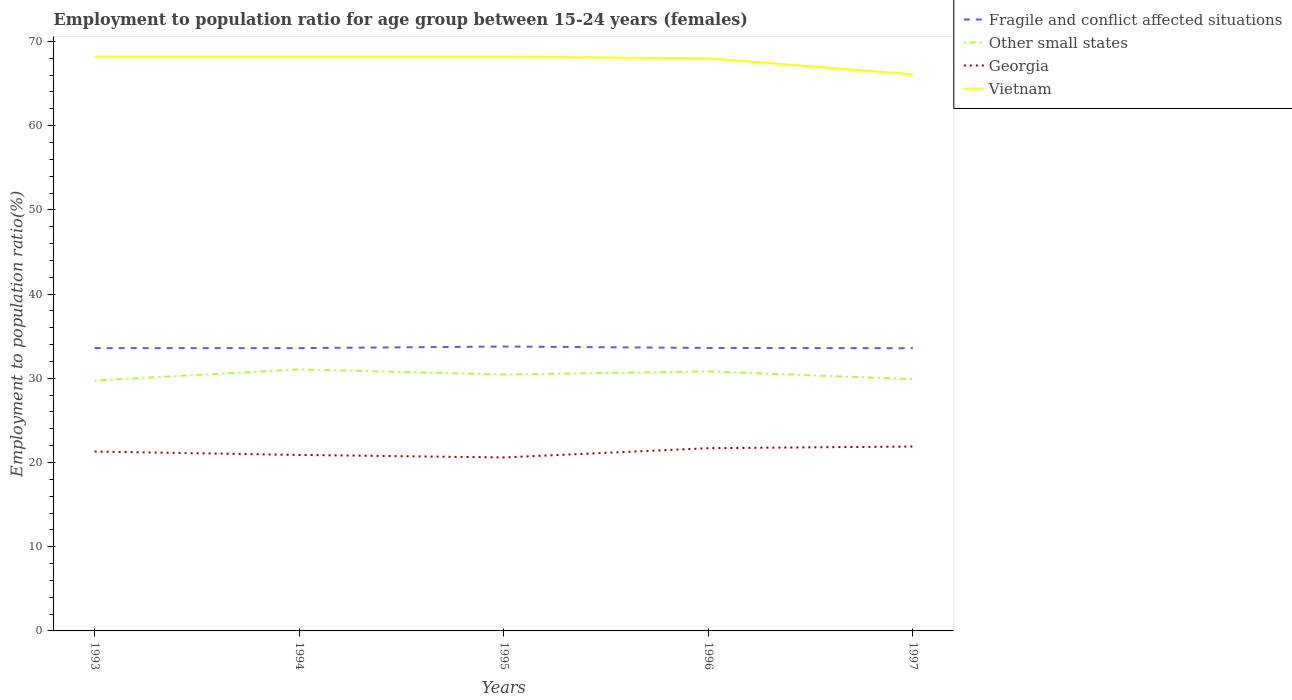How many different coloured lines are there?
Your response must be concise. 4. Does the line corresponding to Vietnam intersect with the line corresponding to Other small states?
Your answer should be very brief. No. Is the number of lines equal to the number of legend labels?
Make the answer very short. Yes. Across all years, what is the maximum employment to population ratio in Fragile and conflict affected situations?
Give a very brief answer. 33.57. In which year was the employment to population ratio in Georgia maximum?
Offer a very short reply. 1995. What is the total employment to population ratio in Georgia in the graph?
Offer a terse response. -1.3. What is the difference between the highest and the second highest employment to population ratio in Other small states?
Make the answer very short. 1.32. What is the difference between the highest and the lowest employment to population ratio in Fragile and conflict affected situations?
Provide a short and direct response. 1. Is the employment to population ratio in Georgia strictly greater than the employment to population ratio in Fragile and conflict affected situations over the years?
Provide a succinct answer. Yes. How many lines are there?
Ensure brevity in your answer.  4. What is the difference between two consecutive major ticks on the Y-axis?
Give a very brief answer. 10. What is the title of the graph?
Offer a very short reply. Employment to population ratio for age group between 15-24 years (females). Does "Fragile and conflict affected situations" appear as one of the legend labels in the graph?
Provide a short and direct response. Yes. What is the label or title of the X-axis?
Your answer should be compact. Years. What is the Employment to population ratio(%) of Fragile and conflict affected situations in 1993?
Your response must be concise. 33.59. What is the Employment to population ratio(%) in Other small states in 1993?
Ensure brevity in your answer.  29.74. What is the Employment to population ratio(%) of Georgia in 1993?
Make the answer very short. 21.3. What is the Employment to population ratio(%) in Vietnam in 1993?
Offer a terse response. 68.2. What is the Employment to population ratio(%) in Fragile and conflict affected situations in 1994?
Offer a very short reply. 33.59. What is the Employment to population ratio(%) in Other small states in 1994?
Your response must be concise. 31.06. What is the Employment to population ratio(%) of Georgia in 1994?
Offer a terse response. 20.9. What is the Employment to population ratio(%) of Vietnam in 1994?
Keep it short and to the point. 68.2. What is the Employment to population ratio(%) in Fragile and conflict affected situations in 1995?
Ensure brevity in your answer.  33.77. What is the Employment to population ratio(%) in Other small states in 1995?
Your answer should be compact. 30.45. What is the Employment to population ratio(%) in Georgia in 1995?
Ensure brevity in your answer.  20.6. What is the Employment to population ratio(%) of Vietnam in 1995?
Your response must be concise. 68.2. What is the Employment to population ratio(%) in Fragile and conflict affected situations in 1996?
Give a very brief answer. 33.6. What is the Employment to population ratio(%) of Other small states in 1996?
Provide a succinct answer. 30.82. What is the Employment to population ratio(%) of Georgia in 1996?
Keep it short and to the point. 21.7. What is the Employment to population ratio(%) of Fragile and conflict affected situations in 1997?
Make the answer very short. 33.57. What is the Employment to population ratio(%) of Other small states in 1997?
Make the answer very short. 29.9. What is the Employment to population ratio(%) of Georgia in 1997?
Keep it short and to the point. 21.9. What is the Employment to population ratio(%) in Vietnam in 1997?
Give a very brief answer. 66.1. Across all years, what is the maximum Employment to population ratio(%) in Fragile and conflict affected situations?
Offer a terse response. 33.77. Across all years, what is the maximum Employment to population ratio(%) in Other small states?
Your answer should be very brief. 31.06. Across all years, what is the maximum Employment to population ratio(%) of Georgia?
Your answer should be compact. 21.9. Across all years, what is the maximum Employment to population ratio(%) in Vietnam?
Ensure brevity in your answer.  68.2. Across all years, what is the minimum Employment to population ratio(%) in Fragile and conflict affected situations?
Provide a succinct answer. 33.57. Across all years, what is the minimum Employment to population ratio(%) of Other small states?
Keep it short and to the point. 29.74. Across all years, what is the minimum Employment to population ratio(%) in Georgia?
Offer a terse response. 20.6. Across all years, what is the minimum Employment to population ratio(%) of Vietnam?
Give a very brief answer. 66.1. What is the total Employment to population ratio(%) in Fragile and conflict affected situations in the graph?
Provide a short and direct response. 168.12. What is the total Employment to population ratio(%) of Other small states in the graph?
Offer a very short reply. 151.96. What is the total Employment to population ratio(%) in Georgia in the graph?
Provide a succinct answer. 106.4. What is the total Employment to population ratio(%) in Vietnam in the graph?
Offer a terse response. 338.7. What is the difference between the Employment to population ratio(%) in Fragile and conflict affected situations in 1993 and that in 1994?
Your answer should be compact. 0. What is the difference between the Employment to population ratio(%) of Other small states in 1993 and that in 1994?
Ensure brevity in your answer.  -1.32. What is the difference between the Employment to population ratio(%) of Fragile and conflict affected situations in 1993 and that in 1995?
Give a very brief answer. -0.19. What is the difference between the Employment to population ratio(%) in Other small states in 1993 and that in 1995?
Offer a very short reply. -0.71. What is the difference between the Employment to population ratio(%) of Georgia in 1993 and that in 1995?
Offer a very short reply. 0.7. What is the difference between the Employment to population ratio(%) in Vietnam in 1993 and that in 1995?
Make the answer very short. 0. What is the difference between the Employment to population ratio(%) of Fragile and conflict affected situations in 1993 and that in 1996?
Ensure brevity in your answer.  -0.02. What is the difference between the Employment to population ratio(%) of Other small states in 1993 and that in 1996?
Provide a succinct answer. -1.08. What is the difference between the Employment to population ratio(%) of Georgia in 1993 and that in 1996?
Offer a terse response. -0.4. What is the difference between the Employment to population ratio(%) in Vietnam in 1993 and that in 1996?
Provide a short and direct response. 0.2. What is the difference between the Employment to population ratio(%) of Fragile and conflict affected situations in 1993 and that in 1997?
Your answer should be compact. 0.01. What is the difference between the Employment to population ratio(%) of Other small states in 1993 and that in 1997?
Keep it short and to the point. -0.17. What is the difference between the Employment to population ratio(%) of Fragile and conflict affected situations in 1994 and that in 1995?
Make the answer very short. -0.19. What is the difference between the Employment to population ratio(%) in Other small states in 1994 and that in 1995?
Give a very brief answer. 0.61. What is the difference between the Employment to population ratio(%) of Georgia in 1994 and that in 1995?
Your response must be concise. 0.3. What is the difference between the Employment to population ratio(%) in Vietnam in 1994 and that in 1995?
Your answer should be very brief. 0. What is the difference between the Employment to population ratio(%) of Fragile and conflict affected situations in 1994 and that in 1996?
Provide a succinct answer. -0.02. What is the difference between the Employment to population ratio(%) of Other small states in 1994 and that in 1996?
Keep it short and to the point. 0.24. What is the difference between the Employment to population ratio(%) in Georgia in 1994 and that in 1996?
Your answer should be compact. -0.8. What is the difference between the Employment to population ratio(%) of Vietnam in 1994 and that in 1996?
Offer a terse response. 0.2. What is the difference between the Employment to population ratio(%) of Fragile and conflict affected situations in 1994 and that in 1997?
Provide a short and direct response. 0.01. What is the difference between the Employment to population ratio(%) in Other small states in 1994 and that in 1997?
Your response must be concise. 1.15. What is the difference between the Employment to population ratio(%) in Georgia in 1994 and that in 1997?
Your answer should be compact. -1. What is the difference between the Employment to population ratio(%) of Fragile and conflict affected situations in 1995 and that in 1996?
Offer a very short reply. 0.17. What is the difference between the Employment to population ratio(%) of Other small states in 1995 and that in 1996?
Provide a succinct answer. -0.37. What is the difference between the Employment to population ratio(%) in Georgia in 1995 and that in 1996?
Offer a terse response. -1.1. What is the difference between the Employment to population ratio(%) in Fragile and conflict affected situations in 1995 and that in 1997?
Your answer should be very brief. 0.2. What is the difference between the Employment to population ratio(%) in Other small states in 1995 and that in 1997?
Your answer should be very brief. 0.54. What is the difference between the Employment to population ratio(%) of Vietnam in 1995 and that in 1997?
Keep it short and to the point. 2.1. What is the difference between the Employment to population ratio(%) of Fragile and conflict affected situations in 1996 and that in 1997?
Ensure brevity in your answer.  0.03. What is the difference between the Employment to population ratio(%) of Other small states in 1996 and that in 1997?
Provide a succinct answer. 0.91. What is the difference between the Employment to population ratio(%) in Vietnam in 1996 and that in 1997?
Provide a short and direct response. 1.9. What is the difference between the Employment to population ratio(%) of Fragile and conflict affected situations in 1993 and the Employment to population ratio(%) of Other small states in 1994?
Offer a very short reply. 2.53. What is the difference between the Employment to population ratio(%) in Fragile and conflict affected situations in 1993 and the Employment to population ratio(%) in Georgia in 1994?
Offer a very short reply. 12.69. What is the difference between the Employment to population ratio(%) in Fragile and conflict affected situations in 1993 and the Employment to population ratio(%) in Vietnam in 1994?
Your answer should be compact. -34.61. What is the difference between the Employment to population ratio(%) in Other small states in 1993 and the Employment to population ratio(%) in Georgia in 1994?
Give a very brief answer. 8.84. What is the difference between the Employment to population ratio(%) in Other small states in 1993 and the Employment to population ratio(%) in Vietnam in 1994?
Ensure brevity in your answer.  -38.46. What is the difference between the Employment to population ratio(%) in Georgia in 1993 and the Employment to population ratio(%) in Vietnam in 1994?
Your answer should be compact. -46.9. What is the difference between the Employment to population ratio(%) in Fragile and conflict affected situations in 1993 and the Employment to population ratio(%) in Other small states in 1995?
Offer a terse response. 3.14. What is the difference between the Employment to population ratio(%) in Fragile and conflict affected situations in 1993 and the Employment to population ratio(%) in Georgia in 1995?
Provide a succinct answer. 12.99. What is the difference between the Employment to population ratio(%) of Fragile and conflict affected situations in 1993 and the Employment to population ratio(%) of Vietnam in 1995?
Offer a terse response. -34.61. What is the difference between the Employment to population ratio(%) in Other small states in 1993 and the Employment to population ratio(%) in Georgia in 1995?
Your answer should be very brief. 9.14. What is the difference between the Employment to population ratio(%) of Other small states in 1993 and the Employment to population ratio(%) of Vietnam in 1995?
Your answer should be compact. -38.46. What is the difference between the Employment to population ratio(%) in Georgia in 1993 and the Employment to population ratio(%) in Vietnam in 1995?
Your answer should be compact. -46.9. What is the difference between the Employment to population ratio(%) in Fragile and conflict affected situations in 1993 and the Employment to population ratio(%) in Other small states in 1996?
Provide a succinct answer. 2.77. What is the difference between the Employment to population ratio(%) of Fragile and conflict affected situations in 1993 and the Employment to population ratio(%) of Georgia in 1996?
Make the answer very short. 11.89. What is the difference between the Employment to population ratio(%) in Fragile and conflict affected situations in 1993 and the Employment to population ratio(%) in Vietnam in 1996?
Make the answer very short. -34.41. What is the difference between the Employment to population ratio(%) of Other small states in 1993 and the Employment to population ratio(%) of Georgia in 1996?
Provide a succinct answer. 8.04. What is the difference between the Employment to population ratio(%) of Other small states in 1993 and the Employment to population ratio(%) of Vietnam in 1996?
Provide a succinct answer. -38.26. What is the difference between the Employment to population ratio(%) of Georgia in 1993 and the Employment to population ratio(%) of Vietnam in 1996?
Your response must be concise. -46.7. What is the difference between the Employment to population ratio(%) of Fragile and conflict affected situations in 1993 and the Employment to population ratio(%) of Other small states in 1997?
Provide a short and direct response. 3.68. What is the difference between the Employment to population ratio(%) in Fragile and conflict affected situations in 1993 and the Employment to population ratio(%) in Georgia in 1997?
Your answer should be compact. 11.69. What is the difference between the Employment to population ratio(%) in Fragile and conflict affected situations in 1993 and the Employment to population ratio(%) in Vietnam in 1997?
Provide a short and direct response. -32.51. What is the difference between the Employment to population ratio(%) in Other small states in 1993 and the Employment to population ratio(%) in Georgia in 1997?
Offer a terse response. 7.84. What is the difference between the Employment to population ratio(%) in Other small states in 1993 and the Employment to population ratio(%) in Vietnam in 1997?
Your answer should be compact. -36.36. What is the difference between the Employment to population ratio(%) of Georgia in 1993 and the Employment to population ratio(%) of Vietnam in 1997?
Your answer should be very brief. -44.8. What is the difference between the Employment to population ratio(%) in Fragile and conflict affected situations in 1994 and the Employment to population ratio(%) in Other small states in 1995?
Your answer should be compact. 3.14. What is the difference between the Employment to population ratio(%) in Fragile and conflict affected situations in 1994 and the Employment to population ratio(%) in Georgia in 1995?
Provide a succinct answer. 12.99. What is the difference between the Employment to population ratio(%) in Fragile and conflict affected situations in 1994 and the Employment to population ratio(%) in Vietnam in 1995?
Your answer should be very brief. -34.61. What is the difference between the Employment to population ratio(%) in Other small states in 1994 and the Employment to population ratio(%) in Georgia in 1995?
Give a very brief answer. 10.46. What is the difference between the Employment to population ratio(%) in Other small states in 1994 and the Employment to population ratio(%) in Vietnam in 1995?
Give a very brief answer. -37.14. What is the difference between the Employment to population ratio(%) in Georgia in 1994 and the Employment to population ratio(%) in Vietnam in 1995?
Your response must be concise. -47.3. What is the difference between the Employment to population ratio(%) in Fragile and conflict affected situations in 1994 and the Employment to population ratio(%) in Other small states in 1996?
Ensure brevity in your answer.  2.77. What is the difference between the Employment to population ratio(%) in Fragile and conflict affected situations in 1994 and the Employment to population ratio(%) in Georgia in 1996?
Your answer should be compact. 11.89. What is the difference between the Employment to population ratio(%) in Fragile and conflict affected situations in 1994 and the Employment to population ratio(%) in Vietnam in 1996?
Your answer should be compact. -34.41. What is the difference between the Employment to population ratio(%) in Other small states in 1994 and the Employment to population ratio(%) in Georgia in 1996?
Make the answer very short. 9.36. What is the difference between the Employment to population ratio(%) in Other small states in 1994 and the Employment to population ratio(%) in Vietnam in 1996?
Your answer should be very brief. -36.94. What is the difference between the Employment to population ratio(%) in Georgia in 1994 and the Employment to population ratio(%) in Vietnam in 1996?
Keep it short and to the point. -47.1. What is the difference between the Employment to population ratio(%) in Fragile and conflict affected situations in 1994 and the Employment to population ratio(%) in Other small states in 1997?
Provide a succinct answer. 3.68. What is the difference between the Employment to population ratio(%) of Fragile and conflict affected situations in 1994 and the Employment to population ratio(%) of Georgia in 1997?
Offer a very short reply. 11.69. What is the difference between the Employment to population ratio(%) of Fragile and conflict affected situations in 1994 and the Employment to population ratio(%) of Vietnam in 1997?
Your response must be concise. -32.51. What is the difference between the Employment to population ratio(%) of Other small states in 1994 and the Employment to population ratio(%) of Georgia in 1997?
Provide a short and direct response. 9.16. What is the difference between the Employment to population ratio(%) in Other small states in 1994 and the Employment to population ratio(%) in Vietnam in 1997?
Your response must be concise. -35.04. What is the difference between the Employment to population ratio(%) in Georgia in 1994 and the Employment to population ratio(%) in Vietnam in 1997?
Ensure brevity in your answer.  -45.2. What is the difference between the Employment to population ratio(%) of Fragile and conflict affected situations in 1995 and the Employment to population ratio(%) of Other small states in 1996?
Give a very brief answer. 2.96. What is the difference between the Employment to population ratio(%) in Fragile and conflict affected situations in 1995 and the Employment to population ratio(%) in Georgia in 1996?
Your response must be concise. 12.07. What is the difference between the Employment to population ratio(%) of Fragile and conflict affected situations in 1995 and the Employment to population ratio(%) of Vietnam in 1996?
Your response must be concise. -34.23. What is the difference between the Employment to population ratio(%) in Other small states in 1995 and the Employment to population ratio(%) in Georgia in 1996?
Make the answer very short. 8.75. What is the difference between the Employment to population ratio(%) in Other small states in 1995 and the Employment to population ratio(%) in Vietnam in 1996?
Make the answer very short. -37.55. What is the difference between the Employment to population ratio(%) in Georgia in 1995 and the Employment to population ratio(%) in Vietnam in 1996?
Make the answer very short. -47.4. What is the difference between the Employment to population ratio(%) in Fragile and conflict affected situations in 1995 and the Employment to population ratio(%) in Other small states in 1997?
Ensure brevity in your answer.  3.87. What is the difference between the Employment to population ratio(%) in Fragile and conflict affected situations in 1995 and the Employment to population ratio(%) in Georgia in 1997?
Your answer should be compact. 11.87. What is the difference between the Employment to population ratio(%) of Fragile and conflict affected situations in 1995 and the Employment to population ratio(%) of Vietnam in 1997?
Your answer should be very brief. -32.33. What is the difference between the Employment to population ratio(%) in Other small states in 1995 and the Employment to population ratio(%) in Georgia in 1997?
Make the answer very short. 8.55. What is the difference between the Employment to population ratio(%) of Other small states in 1995 and the Employment to population ratio(%) of Vietnam in 1997?
Give a very brief answer. -35.65. What is the difference between the Employment to population ratio(%) in Georgia in 1995 and the Employment to population ratio(%) in Vietnam in 1997?
Give a very brief answer. -45.5. What is the difference between the Employment to population ratio(%) in Fragile and conflict affected situations in 1996 and the Employment to population ratio(%) in Other small states in 1997?
Ensure brevity in your answer.  3.7. What is the difference between the Employment to population ratio(%) of Fragile and conflict affected situations in 1996 and the Employment to population ratio(%) of Georgia in 1997?
Offer a very short reply. 11.7. What is the difference between the Employment to population ratio(%) of Fragile and conflict affected situations in 1996 and the Employment to population ratio(%) of Vietnam in 1997?
Your response must be concise. -32.5. What is the difference between the Employment to population ratio(%) of Other small states in 1996 and the Employment to population ratio(%) of Georgia in 1997?
Give a very brief answer. 8.92. What is the difference between the Employment to population ratio(%) in Other small states in 1996 and the Employment to population ratio(%) in Vietnam in 1997?
Offer a very short reply. -35.28. What is the difference between the Employment to population ratio(%) in Georgia in 1996 and the Employment to population ratio(%) in Vietnam in 1997?
Your response must be concise. -44.4. What is the average Employment to population ratio(%) of Fragile and conflict affected situations per year?
Your answer should be very brief. 33.62. What is the average Employment to population ratio(%) of Other small states per year?
Give a very brief answer. 30.39. What is the average Employment to population ratio(%) in Georgia per year?
Your answer should be compact. 21.28. What is the average Employment to population ratio(%) of Vietnam per year?
Give a very brief answer. 67.74. In the year 1993, what is the difference between the Employment to population ratio(%) of Fragile and conflict affected situations and Employment to population ratio(%) of Other small states?
Provide a short and direct response. 3.85. In the year 1993, what is the difference between the Employment to population ratio(%) of Fragile and conflict affected situations and Employment to population ratio(%) of Georgia?
Your response must be concise. 12.29. In the year 1993, what is the difference between the Employment to population ratio(%) of Fragile and conflict affected situations and Employment to population ratio(%) of Vietnam?
Your answer should be very brief. -34.61. In the year 1993, what is the difference between the Employment to population ratio(%) in Other small states and Employment to population ratio(%) in Georgia?
Offer a terse response. 8.44. In the year 1993, what is the difference between the Employment to population ratio(%) in Other small states and Employment to population ratio(%) in Vietnam?
Make the answer very short. -38.46. In the year 1993, what is the difference between the Employment to population ratio(%) in Georgia and Employment to population ratio(%) in Vietnam?
Your answer should be very brief. -46.9. In the year 1994, what is the difference between the Employment to population ratio(%) in Fragile and conflict affected situations and Employment to population ratio(%) in Other small states?
Give a very brief answer. 2.53. In the year 1994, what is the difference between the Employment to population ratio(%) of Fragile and conflict affected situations and Employment to population ratio(%) of Georgia?
Your answer should be very brief. 12.69. In the year 1994, what is the difference between the Employment to population ratio(%) of Fragile and conflict affected situations and Employment to population ratio(%) of Vietnam?
Provide a succinct answer. -34.61. In the year 1994, what is the difference between the Employment to population ratio(%) of Other small states and Employment to population ratio(%) of Georgia?
Provide a short and direct response. 10.16. In the year 1994, what is the difference between the Employment to population ratio(%) in Other small states and Employment to population ratio(%) in Vietnam?
Give a very brief answer. -37.14. In the year 1994, what is the difference between the Employment to population ratio(%) in Georgia and Employment to population ratio(%) in Vietnam?
Keep it short and to the point. -47.3. In the year 1995, what is the difference between the Employment to population ratio(%) of Fragile and conflict affected situations and Employment to population ratio(%) of Other small states?
Give a very brief answer. 3.33. In the year 1995, what is the difference between the Employment to population ratio(%) of Fragile and conflict affected situations and Employment to population ratio(%) of Georgia?
Ensure brevity in your answer.  13.17. In the year 1995, what is the difference between the Employment to population ratio(%) of Fragile and conflict affected situations and Employment to population ratio(%) of Vietnam?
Provide a short and direct response. -34.43. In the year 1995, what is the difference between the Employment to population ratio(%) in Other small states and Employment to population ratio(%) in Georgia?
Keep it short and to the point. 9.85. In the year 1995, what is the difference between the Employment to population ratio(%) in Other small states and Employment to population ratio(%) in Vietnam?
Provide a short and direct response. -37.75. In the year 1995, what is the difference between the Employment to population ratio(%) in Georgia and Employment to population ratio(%) in Vietnam?
Your answer should be compact. -47.6. In the year 1996, what is the difference between the Employment to population ratio(%) in Fragile and conflict affected situations and Employment to population ratio(%) in Other small states?
Your response must be concise. 2.79. In the year 1996, what is the difference between the Employment to population ratio(%) of Fragile and conflict affected situations and Employment to population ratio(%) of Georgia?
Offer a terse response. 11.9. In the year 1996, what is the difference between the Employment to population ratio(%) of Fragile and conflict affected situations and Employment to population ratio(%) of Vietnam?
Your answer should be compact. -34.4. In the year 1996, what is the difference between the Employment to population ratio(%) of Other small states and Employment to population ratio(%) of Georgia?
Your answer should be very brief. 9.12. In the year 1996, what is the difference between the Employment to population ratio(%) of Other small states and Employment to population ratio(%) of Vietnam?
Your answer should be compact. -37.18. In the year 1996, what is the difference between the Employment to population ratio(%) in Georgia and Employment to population ratio(%) in Vietnam?
Your answer should be very brief. -46.3. In the year 1997, what is the difference between the Employment to population ratio(%) in Fragile and conflict affected situations and Employment to population ratio(%) in Other small states?
Provide a succinct answer. 3.67. In the year 1997, what is the difference between the Employment to population ratio(%) in Fragile and conflict affected situations and Employment to population ratio(%) in Georgia?
Offer a very short reply. 11.67. In the year 1997, what is the difference between the Employment to population ratio(%) in Fragile and conflict affected situations and Employment to population ratio(%) in Vietnam?
Keep it short and to the point. -32.53. In the year 1997, what is the difference between the Employment to population ratio(%) of Other small states and Employment to population ratio(%) of Georgia?
Make the answer very short. 8. In the year 1997, what is the difference between the Employment to population ratio(%) in Other small states and Employment to population ratio(%) in Vietnam?
Provide a short and direct response. -36.2. In the year 1997, what is the difference between the Employment to population ratio(%) of Georgia and Employment to population ratio(%) of Vietnam?
Provide a short and direct response. -44.2. What is the ratio of the Employment to population ratio(%) in Other small states in 1993 to that in 1994?
Offer a very short reply. 0.96. What is the ratio of the Employment to population ratio(%) in Georgia in 1993 to that in 1994?
Offer a very short reply. 1.02. What is the ratio of the Employment to population ratio(%) of Fragile and conflict affected situations in 1993 to that in 1995?
Provide a short and direct response. 0.99. What is the ratio of the Employment to population ratio(%) of Other small states in 1993 to that in 1995?
Your answer should be compact. 0.98. What is the ratio of the Employment to population ratio(%) of Georgia in 1993 to that in 1995?
Make the answer very short. 1.03. What is the ratio of the Employment to population ratio(%) in Other small states in 1993 to that in 1996?
Your answer should be compact. 0.96. What is the ratio of the Employment to population ratio(%) of Georgia in 1993 to that in 1996?
Provide a short and direct response. 0.98. What is the ratio of the Employment to population ratio(%) in Fragile and conflict affected situations in 1993 to that in 1997?
Provide a succinct answer. 1. What is the ratio of the Employment to population ratio(%) in Georgia in 1993 to that in 1997?
Your response must be concise. 0.97. What is the ratio of the Employment to population ratio(%) of Vietnam in 1993 to that in 1997?
Provide a succinct answer. 1.03. What is the ratio of the Employment to population ratio(%) of Other small states in 1994 to that in 1995?
Your answer should be compact. 1.02. What is the ratio of the Employment to population ratio(%) in Georgia in 1994 to that in 1995?
Offer a very short reply. 1.01. What is the ratio of the Employment to population ratio(%) in Vietnam in 1994 to that in 1995?
Offer a terse response. 1. What is the ratio of the Employment to population ratio(%) of Fragile and conflict affected situations in 1994 to that in 1996?
Give a very brief answer. 1. What is the ratio of the Employment to population ratio(%) of Other small states in 1994 to that in 1996?
Provide a succinct answer. 1.01. What is the ratio of the Employment to population ratio(%) in Georgia in 1994 to that in 1996?
Your response must be concise. 0.96. What is the ratio of the Employment to population ratio(%) of Vietnam in 1994 to that in 1996?
Keep it short and to the point. 1. What is the ratio of the Employment to population ratio(%) of Other small states in 1994 to that in 1997?
Your answer should be compact. 1.04. What is the ratio of the Employment to population ratio(%) of Georgia in 1994 to that in 1997?
Provide a short and direct response. 0.95. What is the ratio of the Employment to population ratio(%) in Vietnam in 1994 to that in 1997?
Ensure brevity in your answer.  1.03. What is the ratio of the Employment to population ratio(%) in Georgia in 1995 to that in 1996?
Provide a succinct answer. 0.95. What is the ratio of the Employment to population ratio(%) in Vietnam in 1995 to that in 1996?
Provide a short and direct response. 1. What is the ratio of the Employment to population ratio(%) of Fragile and conflict affected situations in 1995 to that in 1997?
Provide a short and direct response. 1.01. What is the ratio of the Employment to population ratio(%) in Other small states in 1995 to that in 1997?
Offer a very short reply. 1.02. What is the ratio of the Employment to population ratio(%) of Georgia in 1995 to that in 1997?
Make the answer very short. 0.94. What is the ratio of the Employment to population ratio(%) in Vietnam in 1995 to that in 1997?
Give a very brief answer. 1.03. What is the ratio of the Employment to population ratio(%) in Other small states in 1996 to that in 1997?
Provide a succinct answer. 1.03. What is the ratio of the Employment to population ratio(%) of Georgia in 1996 to that in 1997?
Offer a terse response. 0.99. What is the ratio of the Employment to population ratio(%) in Vietnam in 1996 to that in 1997?
Your answer should be very brief. 1.03. What is the difference between the highest and the second highest Employment to population ratio(%) of Fragile and conflict affected situations?
Provide a short and direct response. 0.17. What is the difference between the highest and the second highest Employment to population ratio(%) in Other small states?
Your response must be concise. 0.24. What is the difference between the highest and the second highest Employment to population ratio(%) in Vietnam?
Ensure brevity in your answer.  0. What is the difference between the highest and the lowest Employment to population ratio(%) in Fragile and conflict affected situations?
Make the answer very short. 0.2. What is the difference between the highest and the lowest Employment to population ratio(%) of Other small states?
Offer a terse response. 1.32. What is the difference between the highest and the lowest Employment to population ratio(%) in Georgia?
Give a very brief answer. 1.3. What is the difference between the highest and the lowest Employment to population ratio(%) of Vietnam?
Make the answer very short. 2.1. 